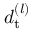Convert formula to latex. <formula><loc_0><loc_0><loc_500><loc_500>d _ { t } ^ { ( l ) }</formula> 